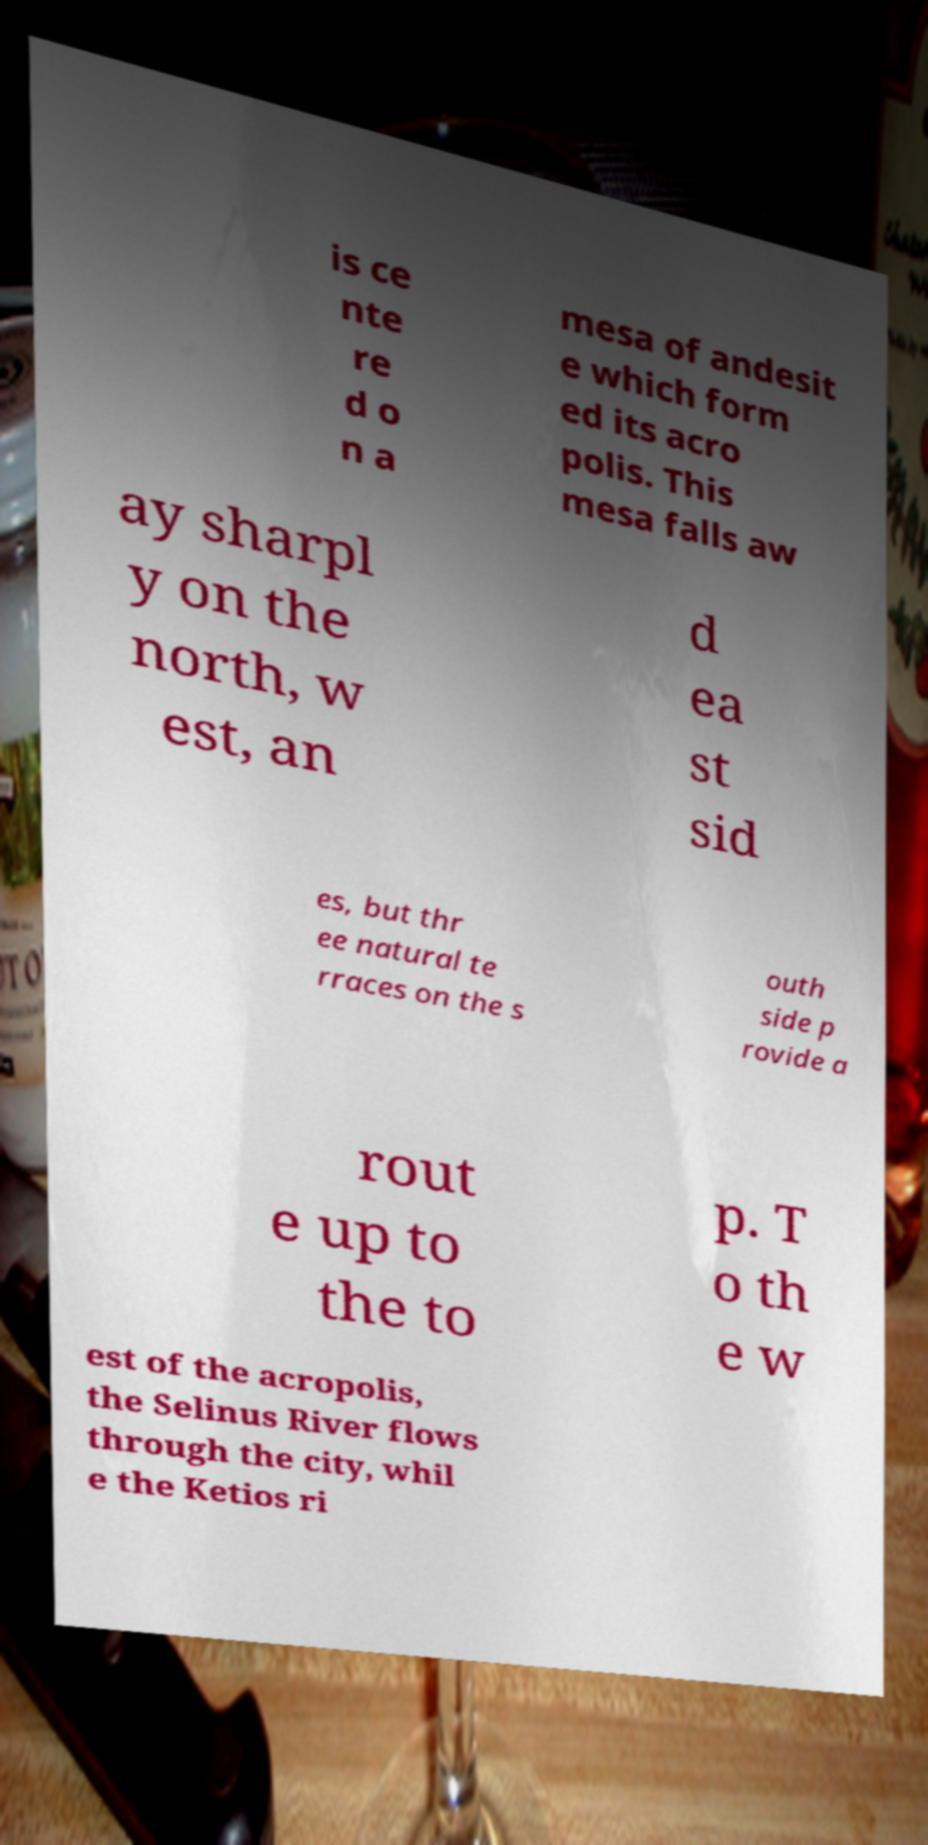Could you extract and type out the text from this image? is ce nte re d o n a mesa of andesit e which form ed its acro polis. This mesa falls aw ay sharpl y on the north, w est, an d ea st sid es, but thr ee natural te rraces on the s outh side p rovide a rout e up to the to p. T o th e w est of the acropolis, the Selinus River flows through the city, whil e the Ketios ri 